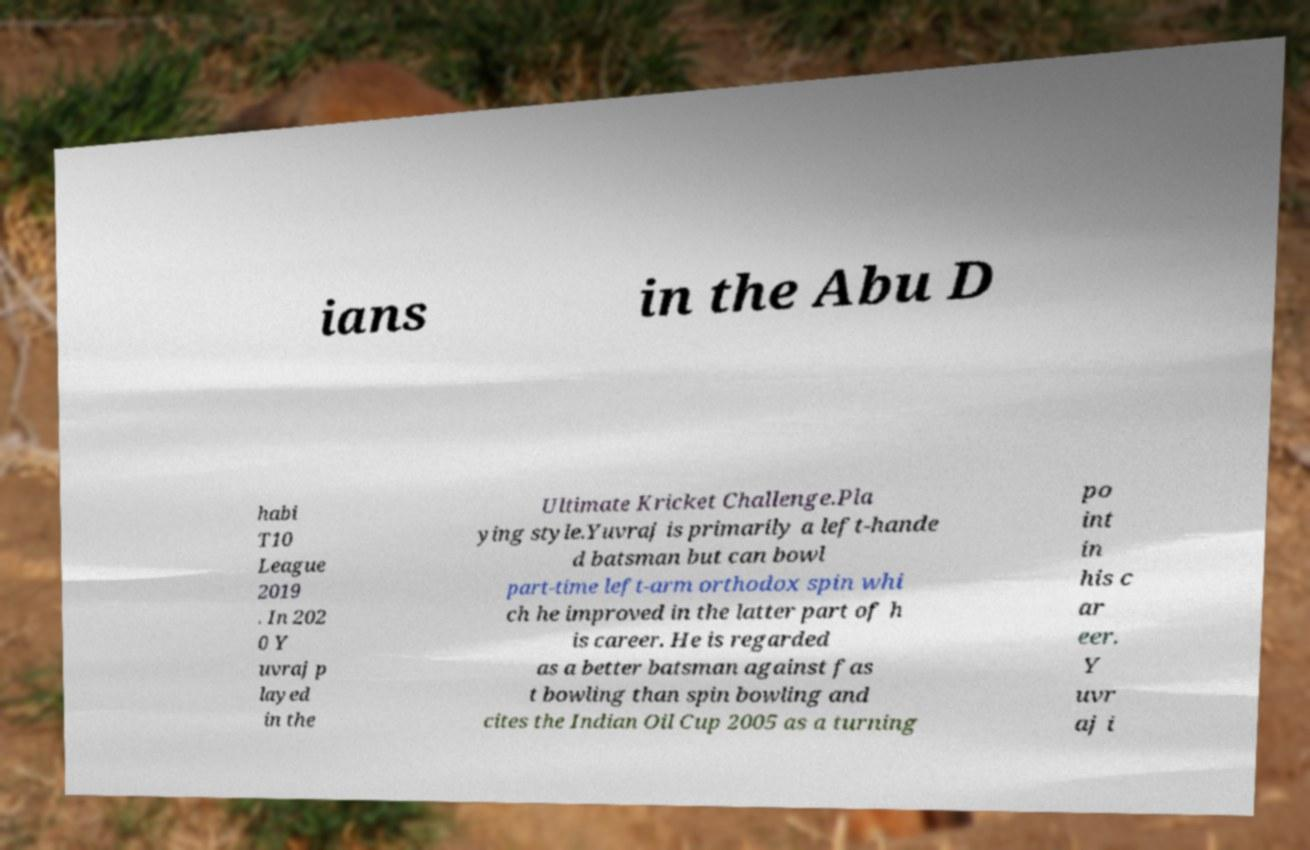Can you accurately transcribe the text from the provided image for me? ians in the Abu D habi T10 League 2019 . In 202 0 Y uvraj p layed in the Ultimate Kricket Challenge.Pla ying style.Yuvraj is primarily a left-hande d batsman but can bowl part-time left-arm orthodox spin whi ch he improved in the latter part of h is career. He is regarded as a better batsman against fas t bowling than spin bowling and cites the Indian Oil Cup 2005 as a turning po int in his c ar eer. Y uvr aj i 